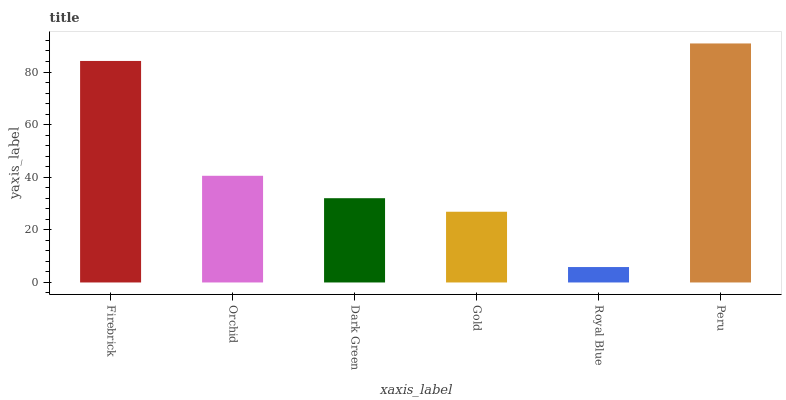Is Royal Blue the minimum?
Answer yes or no. Yes. Is Peru the maximum?
Answer yes or no. Yes. Is Orchid the minimum?
Answer yes or no. No. Is Orchid the maximum?
Answer yes or no. No. Is Firebrick greater than Orchid?
Answer yes or no. Yes. Is Orchid less than Firebrick?
Answer yes or no. Yes. Is Orchid greater than Firebrick?
Answer yes or no. No. Is Firebrick less than Orchid?
Answer yes or no. No. Is Orchid the high median?
Answer yes or no. Yes. Is Dark Green the low median?
Answer yes or no. Yes. Is Dark Green the high median?
Answer yes or no. No. Is Firebrick the low median?
Answer yes or no. No. 